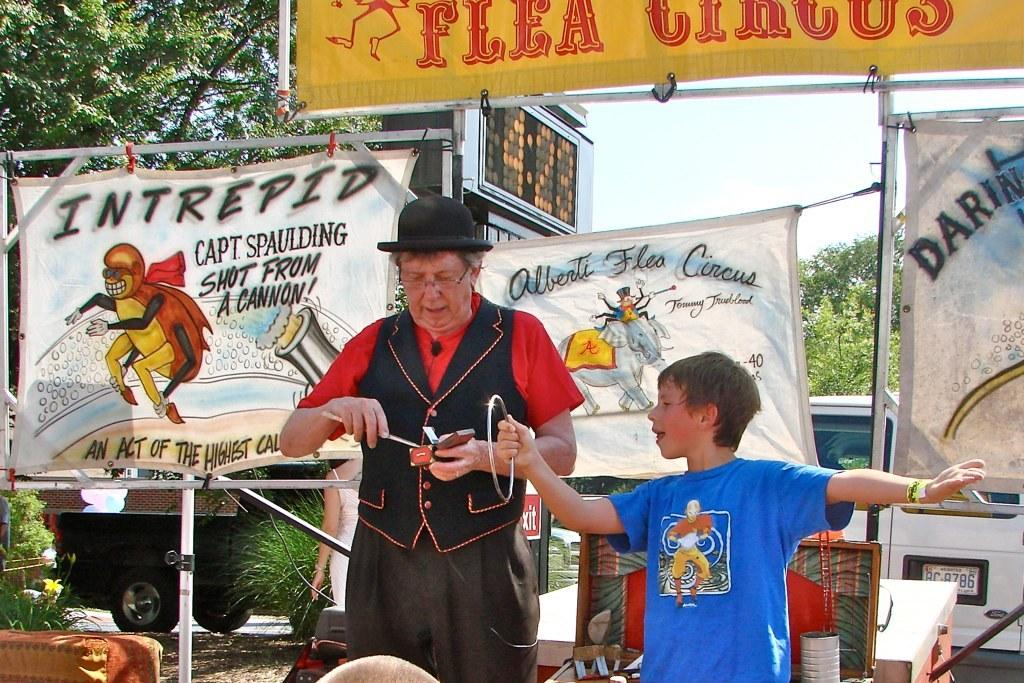How many people are present in the image? There are two persons in the image. What can be seen in the background of the image? There are banners with text and trees in the background of the image. Is there any text visible in the image? Yes, there is text visible at the top of the image and on the banners in the background. What type of alarm can be heard going off in the image? There is no alarm present or audible in the image. How many cats are visible in the image? There are no cats present in the image. 